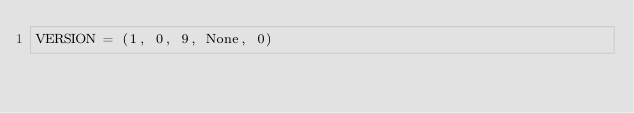Convert code to text. <code><loc_0><loc_0><loc_500><loc_500><_Python_>VERSION = (1, 0, 9, None, 0)

</code> 